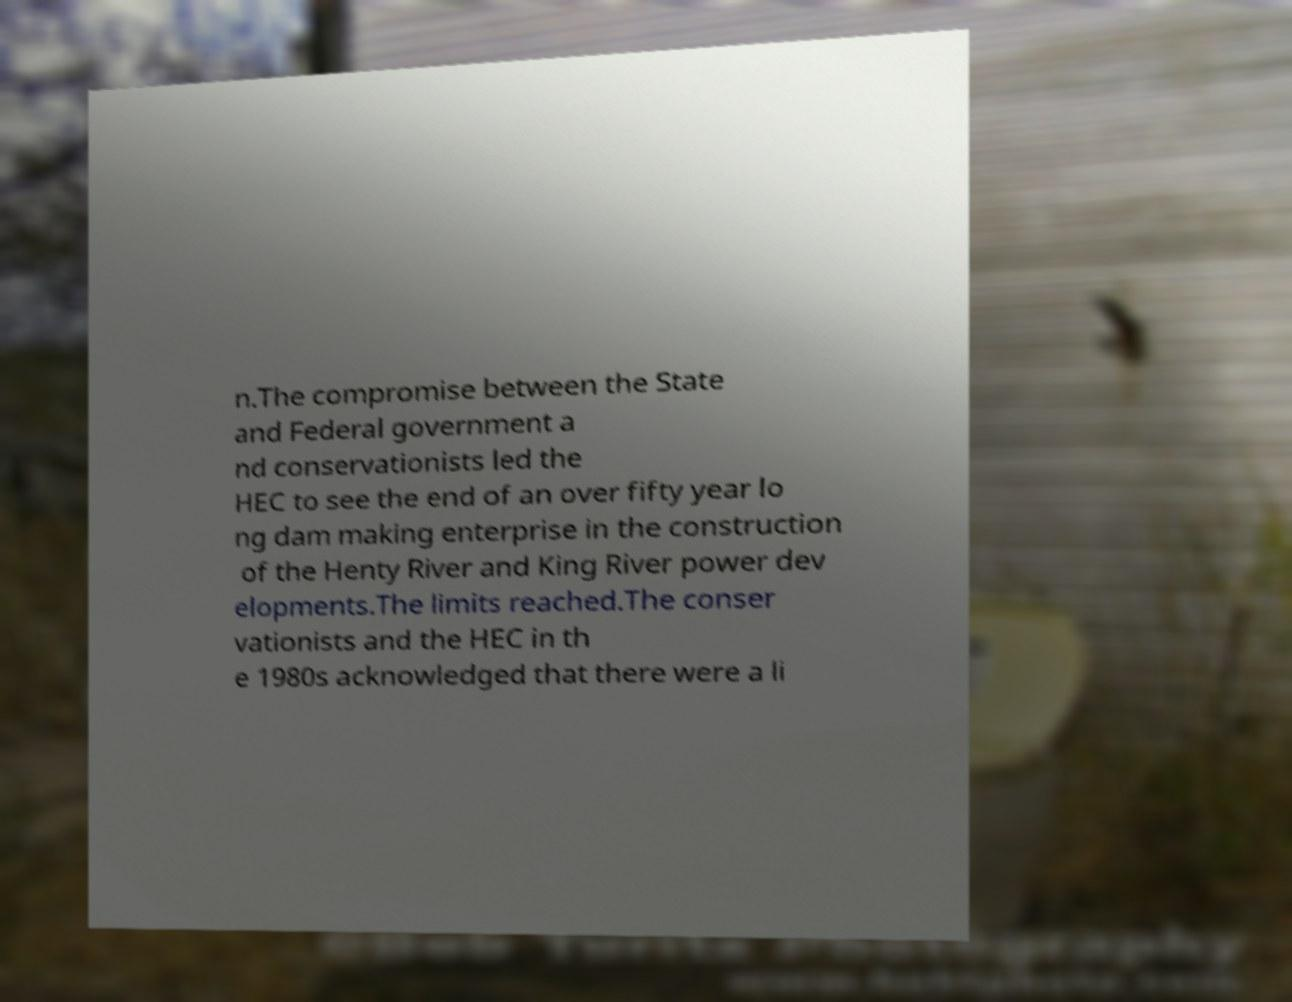There's text embedded in this image that I need extracted. Can you transcribe it verbatim? n.The compromise between the State and Federal government a nd conservationists led the HEC to see the end of an over fifty year lo ng dam making enterprise in the construction of the Henty River and King River power dev elopments.The limits reached.The conser vationists and the HEC in th e 1980s acknowledged that there were a li 